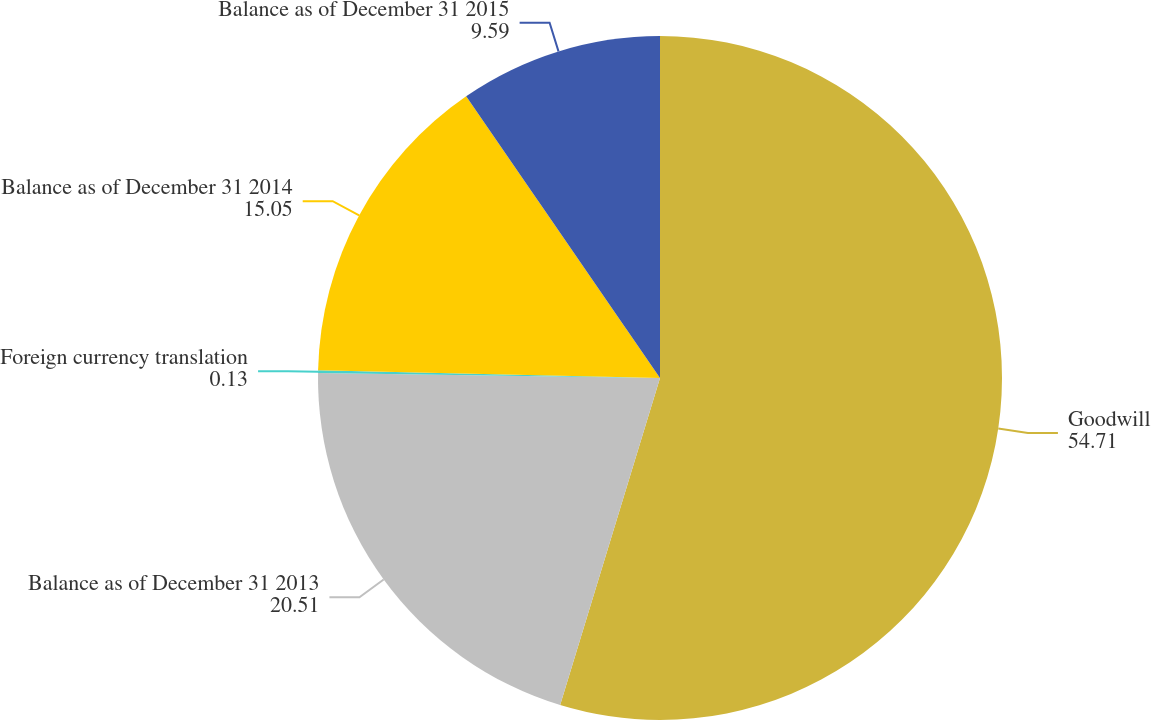<chart> <loc_0><loc_0><loc_500><loc_500><pie_chart><fcel>Goodwill<fcel>Balance as of December 31 2013<fcel>Foreign currency translation<fcel>Balance as of December 31 2014<fcel>Balance as of December 31 2015<nl><fcel>54.71%<fcel>20.51%<fcel>0.13%<fcel>15.05%<fcel>9.59%<nl></chart> 